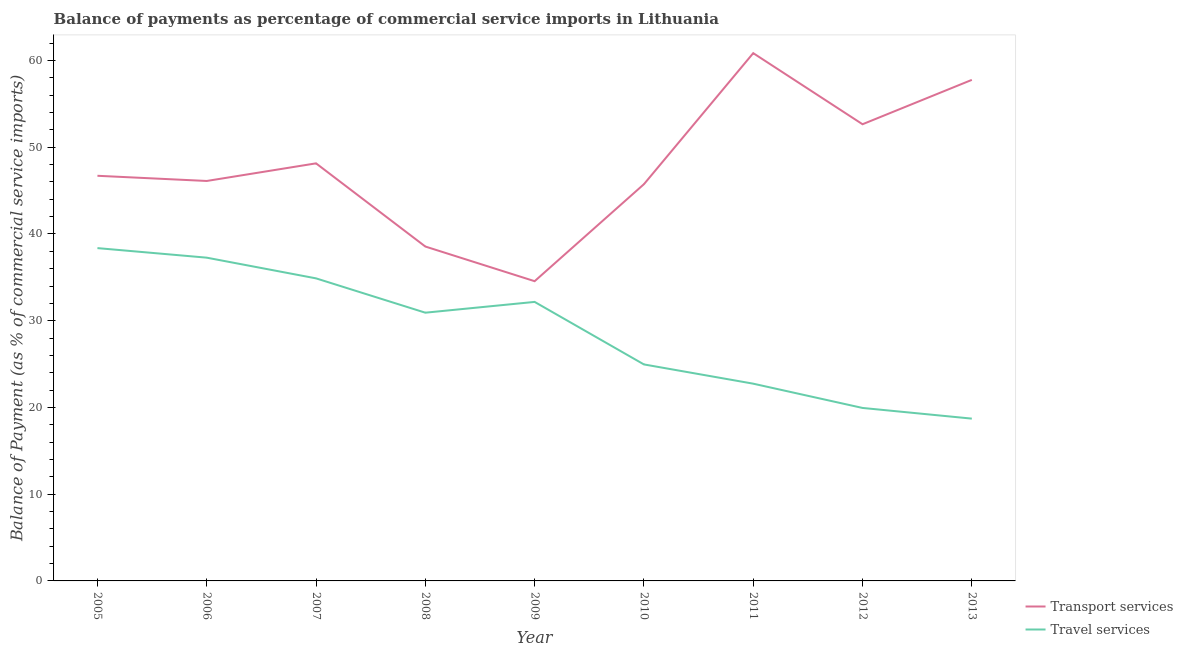What is the balance of payments of transport services in 2011?
Keep it short and to the point. 60.85. Across all years, what is the maximum balance of payments of travel services?
Your answer should be compact. 38.37. Across all years, what is the minimum balance of payments of transport services?
Offer a terse response. 34.56. In which year was the balance of payments of travel services minimum?
Make the answer very short. 2013. What is the total balance of payments of transport services in the graph?
Make the answer very short. 431.08. What is the difference between the balance of payments of travel services in 2005 and that in 2007?
Offer a terse response. 3.49. What is the difference between the balance of payments of travel services in 2007 and the balance of payments of transport services in 2008?
Provide a succinct answer. -3.67. What is the average balance of payments of travel services per year?
Make the answer very short. 28.89. In the year 2008, what is the difference between the balance of payments of travel services and balance of payments of transport services?
Make the answer very short. -7.63. What is the ratio of the balance of payments of travel services in 2006 to that in 2010?
Provide a succinct answer. 1.49. Is the balance of payments of transport services in 2006 less than that in 2013?
Make the answer very short. Yes. What is the difference between the highest and the second highest balance of payments of transport services?
Provide a succinct answer. 3.08. What is the difference between the highest and the lowest balance of payments of transport services?
Ensure brevity in your answer.  26.29. Is the sum of the balance of payments of transport services in 2012 and 2013 greater than the maximum balance of payments of travel services across all years?
Provide a short and direct response. Yes. How many lines are there?
Offer a terse response. 2. Are the values on the major ticks of Y-axis written in scientific E-notation?
Ensure brevity in your answer.  No. Where does the legend appear in the graph?
Give a very brief answer. Bottom right. How many legend labels are there?
Give a very brief answer. 2. How are the legend labels stacked?
Your answer should be compact. Vertical. What is the title of the graph?
Ensure brevity in your answer.  Balance of payments as percentage of commercial service imports in Lithuania. What is the label or title of the X-axis?
Give a very brief answer. Year. What is the label or title of the Y-axis?
Your answer should be compact. Balance of Payment (as % of commercial service imports). What is the Balance of Payment (as % of commercial service imports) in Transport services in 2005?
Ensure brevity in your answer.  46.71. What is the Balance of Payment (as % of commercial service imports) in Travel services in 2005?
Make the answer very short. 38.37. What is the Balance of Payment (as % of commercial service imports) in Transport services in 2006?
Provide a succinct answer. 46.11. What is the Balance of Payment (as % of commercial service imports) in Travel services in 2006?
Your answer should be compact. 37.27. What is the Balance of Payment (as % of commercial service imports) of Transport services in 2007?
Provide a short and direct response. 48.14. What is the Balance of Payment (as % of commercial service imports) in Travel services in 2007?
Your answer should be very brief. 34.88. What is the Balance of Payment (as % of commercial service imports) in Transport services in 2008?
Offer a very short reply. 38.55. What is the Balance of Payment (as % of commercial service imports) of Travel services in 2008?
Your answer should be very brief. 30.93. What is the Balance of Payment (as % of commercial service imports) in Transport services in 2009?
Offer a terse response. 34.56. What is the Balance of Payment (as % of commercial service imports) in Travel services in 2009?
Offer a terse response. 32.17. What is the Balance of Payment (as % of commercial service imports) of Transport services in 2010?
Make the answer very short. 45.74. What is the Balance of Payment (as % of commercial service imports) of Travel services in 2010?
Offer a very short reply. 24.96. What is the Balance of Payment (as % of commercial service imports) in Transport services in 2011?
Ensure brevity in your answer.  60.85. What is the Balance of Payment (as % of commercial service imports) in Travel services in 2011?
Keep it short and to the point. 22.74. What is the Balance of Payment (as % of commercial service imports) in Transport services in 2012?
Ensure brevity in your answer.  52.65. What is the Balance of Payment (as % of commercial service imports) in Travel services in 2012?
Your answer should be very brief. 19.94. What is the Balance of Payment (as % of commercial service imports) of Transport services in 2013?
Your answer should be compact. 57.77. What is the Balance of Payment (as % of commercial service imports) of Travel services in 2013?
Your answer should be compact. 18.71. Across all years, what is the maximum Balance of Payment (as % of commercial service imports) in Transport services?
Provide a succinct answer. 60.85. Across all years, what is the maximum Balance of Payment (as % of commercial service imports) in Travel services?
Your answer should be compact. 38.37. Across all years, what is the minimum Balance of Payment (as % of commercial service imports) in Transport services?
Your answer should be compact. 34.56. Across all years, what is the minimum Balance of Payment (as % of commercial service imports) in Travel services?
Give a very brief answer. 18.71. What is the total Balance of Payment (as % of commercial service imports) of Transport services in the graph?
Your response must be concise. 431.08. What is the total Balance of Payment (as % of commercial service imports) in Travel services in the graph?
Give a very brief answer. 259.97. What is the difference between the Balance of Payment (as % of commercial service imports) of Transport services in 2005 and that in 2006?
Ensure brevity in your answer.  0.6. What is the difference between the Balance of Payment (as % of commercial service imports) in Travel services in 2005 and that in 2006?
Keep it short and to the point. 1.1. What is the difference between the Balance of Payment (as % of commercial service imports) of Transport services in 2005 and that in 2007?
Your answer should be compact. -1.43. What is the difference between the Balance of Payment (as % of commercial service imports) of Travel services in 2005 and that in 2007?
Provide a short and direct response. 3.49. What is the difference between the Balance of Payment (as % of commercial service imports) of Transport services in 2005 and that in 2008?
Offer a terse response. 8.16. What is the difference between the Balance of Payment (as % of commercial service imports) in Travel services in 2005 and that in 2008?
Your response must be concise. 7.44. What is the difference between the Balance of Payment (as % of commercial service imports) of Transport services in 2005 and that in 2009?
Offer a terse response. 12.15. What is the difference between the Balance of Payment (as % of commercial service imports) in Travel services in 2005 and that in 2009?
Provide a short and direct response. 6.2. What is the difference between the Balance of Payment (as % of commercial service imports) in Transport services in 2005 and that in 2010?
Your answer should be very brief. 0.97. What is the difference between the Balance of Payment (as % of commercial service imports) in Travel services in 2005 and that in 2010?
Make the answer very short. 13.41. What is the difference between the Balance of Payment (as % of commercial service imports) of Transport services in 2005 and that in 2011?
Offer a very short reply. -14.14. What is the difference between the Balance of Payment (as % of commercial service imports) of Travel services in 2005 and that in 2011?
Offer a terse response. 15.63. What is the difference between the Balance of Payment (as % of commercial service imports) in Transport services in 2005 and that in 2012?
Give a very brief answer. -5.94. What is the difference between the Balance of Payment (as % of commercial service imports) of Travel services in 2005 and that in 2012?
Provide a short and direct response. 18.43. What is the difference between the Balance of Payment (as % of commercial service imports) of Transport services in 2005 and that in 2013?
Provide a short and direct response. -11.06. What is the difference between the Balance of Payment (as % of commercial service imports) in Travel services in 2005 and that in 2013?
Your answer should be very brief. 19.66. What is the difference between the Balance of Payment (as % of commercial service imports) of Transport services in 2006 and that in 2007?
Ensure brevity in your answer.  -2.03. What is the difference between the Balance of Payment (as % of commercial service imports) of Travel services in 2006 and that in 2007?
Keep it short and to the point. 2.39. What is the difference between the Balance of Payment (as % of commercial service imports) of Transport services in 2006 and that in 2008?
Your answer should be compact. 7.56. What is the difference between the Balance of Payment (as % of commercial service imports) in Travel services in 2006 and that in 2008?
Your answer should be very brief. 6.34. What is the difference between the Balance of Payment (as % of commercial service imports) in Transport services in 2006 and that in 2009?
Provide a short and direct response. 11.55. What is the difference between the Balance of Payment (as % of commercial service imports) in Travel services in 2006 and that in 2009?
Offer a very short reply. 5.1. What is the difference between the Balance of Payment (as % of commercial service imports) of Transport services in 2006 and that in 2010?
Give a very brief answer. 0.37. What is the difference between the Balance of Payment (as % of commercial service imports) in Travel services in 2006 and that in 2010?
Your answer should be compact. 12.31. What is the difference between the Balance of Payment (as % of commercial service imports) of Transport services in 2006 and that in 2011?
Give a very brief answer. -14.74. What is the difference between the Balance of Payment (as % of commercial service imports) of Travel services in 2006 and that in 2011?
Provide a short and direct response. 14.53. What is the difference between the Balance of Payment (as % of commercial service imports) in Transport services in 2006 and that in 2012?
Your response must be concise. -6.54. What is the difference between the Balance of Payment (as % of commercial service imports) of Travel services in 2006 and that in 2012?
Keep it short and to the point. 17.33. What is the difference between the Balance of Payment (as % of commercial service imports) of Transport services in 2006 and that in 2013?
Ensure brevity in your answer.  -11.65. What is the difference between the Balance of Payment (as % of commercial service imports) of Travel services in 2006 and that in 2013?
Your answer should be compact. 18.56. What is the difference between the Balance of Payment (as % of commercial service imports) in Transport services in 2007 and that in 2008?
Make the answer very short. 9.59. What is the difference between the Balance of Payment (as % of commercial service imports) of Travel services in 2007 and that in 2008?
Offer a very short reply. 3.96. What is the difference between the Balance of Payment (as % of commercial service imports) of Transport services in 2007 and that in 2009?
Give a very brief answer. 13.59. What is the difference between the Balance of Payment (as % of commercial service imports) of Travel services in 2007 and that in 2009?
Provide a short and direct response. 2.71. What is the difference between the Balance of Payment (as % of commercial service imports) in Transport services in 2007 and that in 2010?
Provide a short and direct response. 2.4. What is the difference between the Balance of Payment (as % of commercial service imports) in Travel services in 2007 and that in 2010?
Make the answer very short. 9.92. What is the difference between the Balance of Payment (as % of commercial service imports) in Transport services in 2007 and that in 2011?
Give a very brief answer. -12.71. What is the difference between the Balance of Payment (as % of commercial service imports) in Travel services in 2007 and that in 2011?
Your answer should be compact. 12.14. What is the difference between the Balance of Payment (as % of commercial service imports) in Transport services in 2007 and that in 2012?
Give a very brief answer. -4.51. What is the difference between the Balance of Payment (as % of commercial service imports) in Travel services in 2007 and that in 2012?
Your response must be concise. 14.94. What is the difference between the Balance of Payment (as % of commercial service imports) in Transport services in 2007 and that in 2013?
Keep it short and to the point. -9.62. What is the difference between the Balance of Payment (as % of commercial service imports) in Travel services in 2007 and that in 2013?
Keep it short and to the point. 16.17. What is the difference between the Balance of Payment (as % of commercial service imports) of Transport services in 2008 and that in 2009?
Give a very brief answer. 3.99. What is the difference between the Balance of Payment (as % of commercial service imports) of Travel services in 2008 and that in 2009?
Your answer should be very brief. -1.24. What is the difference between the Balance of Payment (as % of commercial service imports) of Transport services in 2008 and that in 2010?
Make the answer very short. -7.19. What is the difference between the Balance of Payment (as % of commercial service imports) of Travel services in 2008 and that in 2010?
Offer a terse response. 5.97. What is the difference between the Balance of Payment (as % of commercial service imports) of Transport services in 2008 and that in 2011?
Ensure brevity in your answer.  -22.3. What is the difference between the Balance of Payment (as % of commercial service imports) of Travel services in 2008 and that in 2011?
Keep it short and to the point. 8.18. What is the difference between the Balance of Payment (as % of commercial service imports) in Transport services in 2008 and that in 2012?
Your answer should be compact. -14.1. What is the difference between the Balance of Payment (as % of commercial service imports) in Travel services in 2008 and that in 2012?
Offer a terse response. 10.98. What is the difference between the Balance of Payment (as % of commercial service imports) in Transport services in 2008 and that in 2013?
Offer a very short reply. -19.21. What is the difference between the Balance of Payment (as % of commercial service imports) in Travel services in 2008 and that in 2013?
Your answer should be compact. 12.21. What is the difference between the Balance of Payment (as % of commercial service imports) in Transport services in 2009 and that in 2010?
Give a very brief answer. -11.18. What is the difference between the Balance of Payment (as % of commercial service imports) in Travel services in 2009 and that in 2010?
Your answer should be very brief. 7.21. What is the difference between the Balance of Payment (as % of commercial service imports) of Transport services in 2009 and that in 2011?
Keep it short and to the point. -26.29. What is the difference between the Balance of Payment (as % of commercial service imports) in Travel services in 2009 and that in 2011?
Your answer should be very brief. 9.43. What is the difference between the Balance of Payment (as % of commercial service imports) in Transport services in 2009 and that in 2012?
Give a very brief answer. -18.09. What is the difference between the Balance of Payment (as % of commercial service imports) of Travel services in 2009 and that in 2012?
Offer a very short reply. 12.23. What is the difference between the Balance of Payment (as % of commercial service imports) of Transport services in 2009 and that in 2013?
Your answer should be very brief. -23.21. What is the difference between the Balance of Payment (as % of commercial service imports) in Travel services in 2009 and that in 2013?
Offer a terse response. 13.46. What is the difference between the Balance of Payment (as % of commercial service imports) in Transport services in 2010 and that in 2011?
Your response must be concise. -15.11. What is the difference between the Balance of Payment (as % of commercial service imports) of Travel services in 2010 and that in 2011?
Make the answer very short. 2.22. What is the difference between the Balance of Payment (as % of commercial service imports) of Transport services in 2010 and that in 2012?
Offer a terse response. -6.91. What is the difference between the Balance of Payment (as % of commercial service imports) in Travel services in 2010 and that in 2012?
Offer a terse response. 5.02. What is the difference between the Balance of Payment (as % of commercial service imports) of Transport services in 2010 and that in 2013?
Provide a succinct answer. -12.03. What is the difference between the Balance of Payment (as % of commercial service imports) in Travel services in 2010 and that in 2013?
Ensure brevity in your answer.  6.25. What is the difference between the Balance of Payment (as % of commercial service imports) in Transport services in 2011 and that in 2012?
Your answer should be very brief. 8.2. What is the difference between the Balance of Payment (as % of commercial service imports) of Travel services in 2011 and that in 2012?
Provide a succinct answer. 2.8. What is the difference between the Balance of Payment (as % of commercial service imports) in Transport services in 2011 and that in 2013?
Offer a very short reply. 3.08. What is the difference between the Balance of Payment (as % of commercial service imports) of Travel services in 2011 and that in 2013?
Give a very brief answer. 4.03. What is the difference between the Balance of Payment (as % of commercial service imports) of Transport services in 2012 and that in 2013?
Offer a very short reply. -5.11. What is the difference between the Balance of Payment (as % of commercial service imports) of Travel services in 2012 and that in 2013?
Ensure brevity in your answer.  1.23. What is the difference between the Balance of Payment (as % of commercial service imports) of Transport services in 2005 and the Balance of Payment (as % of commercial service imports) of Travel services in 2006?
Your answer should be very brief. 9.44. What is the difference between the Balance of Payment (as % of commercial service imports) in Transport services in 2005 and the Balance of Payment (as % of commercial service imports) in Travel services in 2007?
Provide a short and direct response. 11.83. What is the difference between the Balance of Payment (as % of commercial service imports) of Transport services in 2005 and the Balance of Payment (as % of commercial service imports) of Travel services in 2008?
Provide a succinct answer. 15.78. What is the difference between the Balance of Payment (as % of commercial service imports) in Transport services in 2005 and the Balance of Payment (as % of commercial service imports) in Travel services in 2009?
Your answer should be compact. 14.54. What is the difference between the Balance of Payment (as % of commercial service imports) of Transport services in 2005 and the Balance of Payment (as % of commercial service imports) of Travel services in 2010?
Offer a terse response. 21.75. What is the difference between the Balance of Payment (as % of commercial service imports) of Transport services in 2005 and the Balance of Payment (as % of commercial service imports) of Travel services in 2011?
Your answer should be compact. 23.97. What is the difference between the Balance of Payment (as % of commercial service imports) of Transport services in 2005 and the Balance of Payment (as % of commercial service imports) of Travel services in 2012?
Your answer should be very brief. 26.77. What is the difference between the Balance of Payment (as % of commercial service imports) of Transport services in 2005 and the Balance of Payment (as % of commercial service imports) of Travel services in 2013?
Your answer should be very brief. 28. What is the difference between the Balance of Payment (as % of commercial service imports) of Transport services in 2006 and the Balance of Payment (as % of commercial service imports) of Travel services in 2007?
Provide a short and direct response. 11.23. What is the difference between the Balance of Payment (as % of commercial service imports) of Transport services in 2006 and the Balance of Payment (as % of commercial service imports) of Travel services in 2008?
Ensure brevity in your answer.  15.19. What is the difference between the Balance of Payment (as % of commercial service imports) in Transport services in 2006 and the Balance of Payment (as % of commercial service imports) in Travel services in 2009?
Your response must be concise. 13.94. What is the difference between the Balance of Payment (as % of commercial service imports) in Transport services in 2006 and the Balance of Payment (as % of commercial service imports) in Travel services in 2010?
Provide a succinct answer. 21.15. What is the difference between the Balance of Payment (as % of commercial service imports) in Transport services in 2006 and the Balance of Payment (as % of commercial service imports) in Travel services in 2011?
Offer a terse response. 23.37. What is the difference between the Balance of Payment (as % of commercial service imports) in Transport services in 2006 and the Balance of Payment (as % of commercial service imports) in Travel services in 2012?
Offer a terse response. 26.17. What is the difference between the Balance of Payment (as % of commercial service imports) of Transport services in 2006 and the Balance of Payment (as % of commercial service imports) of Travel services in 2013?
Your answer should be compact. 27.4. What is the difference between the Balance of Payment (as % of commercial service imports) of Transport services in 2007 and the Balance of Payment (as % of commercial service imports) of Travel services in 2008?
Your response must be concise. 17.22. What is the difference between the Balance of Payment (as % of commercial service imports) in Transport services in 2007 and the Balance of Payment (as % of commercial service imports) in Travel services in 2009?
Give a very brief answer. 15.97. What is the difference between the Balance of Payment (as % of commercial service imports) in Transport services in 2007 and the Balance of Payment (as % of commercial service imports) in Travel services in 2010?
Give a very brief answer. 23.18. What is the difference between the Balance of Payment (as % of commercial service imports) in Transport services in 2007 and the Balance of Payment (as % of commercial service imports) in Travel services in 2011?
Provide a succinct answer. 25.4. What is the difference between the Balance of Payment (as % of commercial service imports) in Transport services in 2007 and the Balance of Payment (as % of commercial service imports) in Travel services in 2012?
Offer a terse response. 28.2. What is the difference between the Balance of Payment (as % of commercial service imports) of Transport services in 2007 and the Balance of Payment (as % of commercial service imports) of Travel services in 2013?
Your response must be concise. 29.43. What is the difference between the Balance of Payment (as % of commercial service imports) of Transport services in 2008 and the Balance of Payment (as % of commercial service imports) of Travel services in 2009?
Your answer should be very brief. 6.38. What is the difference between the Balance of Payment (as % of commercial service imports) in Transport services in 2008 and the Balance of Payment (as % of commercial service imports) in Travel services in 2010?
Give a very brief answer. 13.59. What is the difference between the Balance of Payment (as % of commercial service imports) of Transport services in 2008 and the Balance of Payment (as % of commercial service imports) of Travel services in 2011?
Keep it short and to the point. 15.81. What is the difference between the Balance of Payment (as % of commercial service imports) of Transport services in 2008 and the Balance of Payment (as % of commercial service imports) of Travel services in 2012?
Offer a terse response. 18.61. What is the difference between the Balance of Payment (as % of commercial service imports) of Transport services in 2008 and the Balance of Payment (as % of commercial service imports) of Travel services in 2013?
Offer a very short reply. 19.84. What is the difference between the Balance of Payment (as % of commercial service imports) in Transport services in 2009 and the Balance of Payment (as % of commercial service imports) in Travel services in 2010?
Make the answer very short. 9.6. What is the difference between the Balance of Payment (as % of commercial service imports) of Transport services in 2009 and the Balance of Payment (as % of commercial service imports) of Travel services in 2011?
Make the answer very short. 11.82. What is the difference between the Balance of Payment (as % of commercial service imports) of Transport services in 2009 and the Balance of Payment (as % of commercial service imports) of Travel services in 2012?
Ensure brevity in your answer.  14.61. What is the difference between the Balance of Payment (as % of commercial service imports) of Transport services in 2009 and the Balance of Payment (as % of commercial service imports) of Travel services in 2013?
Offer a very short reply. 15.85. What is the difference between the Balance of Payment (as % of commercial service imports) of Transport services in 2010 and the Balance of Payment (as % of commercial service imports) of Travel services in 2011?
Provide a short and direct response. 23. What is the difference between the Balance of Payment (as % of commercial service imports) of Transport services in 2010 and the Balance of Payment (as % of commercial service imports) of Travel services in 2012?
Provide a short and direct response. 25.8. What is the difference between the Balance of Payment (as % of commercial service imports) of Transport services in 2010 and the Balance of Payment (as % of commercial service imports) of Travel services in 2013?
Keep it short and to the point. 27.03. What is the difference between the Balance of Payment (as % of commercial service imports) in Transport services in 2011 and the Balance of Payment (as % of commercial service imports) in Travel services in 2012?
Provide a succinct answer. 40.91. What is the difference between the Balance of Payment (as % of commercial service imports) in Transport services in 2011 and the Balance of Payment (as % of commercial service imports) in Travel services in 2013?
Offer a terse response. 42.14. What is the difference between the Balance of Payment (as % of commercial service imports) in Transport services in 2012 and the Balance of Payment (as % of commercial service imports) in Travel services in 2013?
Provide a short and direct response. 33.94. What is the average Balance of Payment (as % of commercial service imports) of Transport services per year?
Ensure brevity in your answer.  47.9. What is the average Balance of Payment (as % of commercial service imports) of Travel services per year?
Provide a short and direct response. 28.89. In the year 2005, what is the difference between the Balance of Payment (as % of commercial service imports) of Transport services and Balance of Payment (as % of commercial service imports) of Travel services?
Offer a terse response. 8.34. In the year 2006, what is the difference between the Balance of Payment (as % of commercial service imports) of Transport services and Balance of Payment (as % of commercial service imports) of Travel services?
Offer a very short reply. 8.84. In the year 2007, what is the difference between the Balance of Payment (as % of commercial service imports) in Transport services and Balance of Payment (as % of commercial service imports) in Travel services?
Your answer should be very brief. 13.26. In the year 2008, what is the difference between the Balance of Payment (as % of commercial service imports) in Transport services and Balance of Payment (as % of commercial service imports) in Travel services?
Make the answer very short. 7.63. In the year 2009, what is the difference between the Balance of Payment (as % of commercial service imports) in Transport services and Balance of Payment (as % of commercial service imports) in Travel services?
Provide a succinct answer. 2.39. In the year 2010, what is the difference between the Balance of Payment (as % of commercial service imports) of Transport services and Balance of Payment (as % of commercial service imports) of Travel services?
Your answer should be very brief. 20.78. In the year 2011, what is the difference between the Balance of Payment (as % of commercial service imports) of Transport services and Balance of Payment (as % of commercial service imports) of Travel services?
Your answer should be very brief. 38.11. In the year 2012, what is the difference between the Balance of Payment (as % of commercial service imports) in Transport services and Balance of Payment (as % of commercial service imports) in Travel services?
Offer a very short reply. 32.71. In the year 2013, what is the difference between the Balance of Payment (as % of commercial service imports) of Transport services and Balance of Payment (as % of commercial service imports) of Travel services?
Make the answer very short. 39.05. What is the ratio of the Balance of Payment (as % of commercial service imports) in Travel services in 2005 to that in 2006?
Offer a very short reply. 1.03. What is the ratio of the Balance of Payment (as % of commercial service imports) of Transport services in 2005 to that in 2007?
Give a very brief answer. 0.97. What is the ratio of the Balance of Payment (as % of commercial service imports) in Travel services in 2005 to that in 2007?
Offer a very short reply. 1.1. What is the ratio of the Balance of Payment (as % of commercial service imports) in Transport services in 2005 to that in 2008?
Ensure brevity in your answer.  1.21. What is the ratio of the Balance of Payment (as % of commercial service imports) of Travel services in 2005 to that in 2008?
Offer a very short reply. 1.24. What is the ratio of the Balance of Payment (as % of commercial service imports) of Transport services in 2005 to that in 2009?
Your answer should be very brief. 1.35. What is the ratio of the Balance of Payment (as % of commercial service imports) in Travel services in 2005 to that in 2009?
Your response must be concise. 1.19. What is the ratio of the Balance of Payment (as % of commercial service imports) of Transport services in 2005 to that in 2010?
Ensure brevity in your answer.  1.02. What is the ratio of the Balance of Payment (as % of commercial service imports) of Travel services in 2005 to that in 2010?
Make the answer very short. 1.54. What is the ratio of the Balance of Payment (as % of commercial service imports) in Transport services in 2005 to that in 2011?
Your answer should be very brief. 0.77. What is the ratio of the Balance of Payment (as % of commercial service imports) of Travel services in 2005 to that in 2011?
Give a very brief answer. 1.69. What is the ratio of the Balance of Payment (as % of commercial service imports) of Transport services in 2005 to that in 2012?
Offer a very short reply. 0.89. What is the ratio of the Balance of Payment (as % of commercial service imports) of Travel services in 2005 to that in 2012?
Ensure brevity in your answer.  1.92. What is the ratio of the Balance of Payment (as % of commercial service imports) in Transport services in 2005 to that in 2013?
Offer a terse response. 0.81. What is the ratio of the Balance of Payment (as % of commercial service imports) of Travel services in 2005 to that in 2013?
Offer a terse response. 2.05. What is the ratio of the Balance of Payment (as % of commercial service imports) of Transport services in 2006 to that in 2007?
Make the answer very short. 0.96. What is the ratio of the Balance of Payment (as % of commercial service imports) in Travel services in 2006 to that in 2007?
Provide a short and direct response. 1.07. What is the ratio of the Balance of Payment (as % of commercial service imports) in Transport services in 2006 to that in 2008?
Your answer should be compact. 1.2. What is the ratio of the Balance of Payment (as % of commercial service imports) of Travel services in 2006 to that in 2008?
Ensure brevity in your answer.  1.21. What is the ratio of the Balance of Payment (as % of commercial service imports) in Transport services in 2006 to that in 2009?
Give a very brief answer. 1.33. What is the ratio of the Balance of Payment (as % of commercial service imports) of Travel services in 2006 to that in 2009?
Provide a succinct answer. 1.16. What is the ratio of the Balance of Payment (as % of commercial service imports) of Transport services in 2006 to that in 2010?
Make the answer very short. 1.01. What is the ratio of the Balance of Payment (as % of commercial service imports) of Travel services in 2006 to that in 2010?
Give a very brief answer. 1.49. What is the ratio of the Balance of Payment (as % of commercial service imports) in Transport services in 2006 to that in 2011?
Ensure brevity in your answer.  0.76. What is the ratio of the Balance of Payment (as % of commercial service imports) of Travel services in 2006 to that in 2011?
Keep it short and to the point. 1.64. What is the ratio of the Balance of Payment (as % of commercial service imports) of Transport services in 2006 to that in 2012?
Keep it short and to the point. 0.88. What is the ratio of the Balance of Payment (as % of commercial service imports) of Travel services in 2006 to that in 2012?
Ensure brevity in your answer.  1.87. What is the ratio of the Balance of Payment (as % of commercial service imports) in Transport services in 2006 to that in 2013?
Provide a short and direct response. 0.8. What is the ratio of the Balance of Payment (as % of commercial service imports) of Travel services in 2006 to that in 2013?
Your answer should be compact. 1.99. What is the ratio of the Balance of Payment (as % of commercial service imports) of Transport services in 2007 to that in 2008?
Ensure brevity in your answer.  1.25. What is the ratio of the Balance of Payment (as % of commercial service imports) in Travel services in 2007 to that in 2008?
Keep it short and to the point. 1.13. What is the ratio of the Balance of Payment (as % of commercial service imports) of Transport services in 2007 to that in 2009?
Keep it short and to the point. 1.39. What is the ratio of the Balance of Payment (as % of commercial service imports) in Travel services in 2007 to that in 2009?
Your answer should be compact. 1.08. What is the ratio of the Balance of Payment (as % of commercial service imports) of Transport services in 2007 to that in 2010?
Your answer should be compact. 1.05. What is the ratio of the Balance of Payment (as % of commercial service imports) in Travel services in 2007 to that in 2010?
Your response must be concise. 1.4. What is the ratio of the Balance of Payment (as % of commercial service imports) of Transport services in 2007 to that in 2011?
Your answer should be compact. 0.79. What is the ratio of the Balance of Payment (as % of commercial service imports) of Travel services in 2007 to that in 2011?
Your answer should be very brief. 1.53. What is the ratio of the Balance of Payment (as % of commercial service imports) of Transport services in 2007 to that in 2012?
Your answer should be very brief. 0.91. What is the ratio of the Balance of Payment (as % of commercial service imports) in Travel services in 2007 to that in 2012?
Provide a succinct answer. 1.75. What is the ratio of the Balance of Payment (as % of commercial service imports) in Transport services in 2007 to that in 2013?
Provide a succinct answer. 0.83. What is the ratio of the Balance of Payment (as % of commercial service imports) of Travel services in 2007 to that in 2013?
Provide a succinct answer. 1.86. What is the ratio of the Balance of Payment (as % of commercial service imports) of Transport services in 2008 to that in 2009?
Your response must be concise. 1.12. What is the ratio of the Balance of Payment (as % of commercial service imports) in Travel services in 2008 to that in 2009?
Provide a short and direct response. 0.96. What is the ratio of the Balance of Payment (as % of commercial service imports) in Transport services in 2008 to that in 2010?
Provide a succinct answer. 0.84. What is the ratio of the Balance of Payment (as % of commercial service imports) in Travel services in 2008 to that in 2010?
Your answer should be compact. 1.24. What is the ratio of the Balance of Payment (as % of commercial service imports) in Transport services in 2008 to that in 2011?
Give a very brief answer. 0.63. What is the ratio of the Balance of Payment (as % of commercial service imports) in Travel services in 2008 to that in 2011?
Your answer should be very brief. 1.36. What is the ratio of the Balance of Payment (as % of commercial service imports) of Transport services in 2008 to that in 2012?
Offer a very short reply. 0.73. What is the ratio of the Balance of Payment (as % of commercial service imports) in Travel services in 2008 to that in 2012?
Keep it short and to the point. 1.55. What is the ratio of the Balance of Payment (as % of commercial service imports) of Transport services in 2008 to that in 2013?
Give a very brief answer. 0.67. What is the ratio of the Balance of Payment (as % of commercial service imports) of Travel services in 2008 to that in 2013?
Ensure brevity in your answer.  1.65. What is the ratio of the Balance of Payment (as % of commercial service imports) of Transport services in 2009 to that in 2010?
Ensure brevity in your answer.  0.76. What is the ratio of the Balance of Payment (as % of commercial service imports) in Travel services in 2009 to that in 2010?
Offer a terse response. 1.29. What is the ratio of the Balance of Payment (as % of commercial service imports) in Transport services in 2009 to that in 2011?
Offer a terse response. 0.57. What is the ratio of the Balance of Payment (as % of commercial service imports) of Travel services in 2009 to that in 2011?
Provide a succinct answer. 1.41. What is the ratio of the Balance of Payment (as % of commercial service imports) in Transport services in 2009 to that in 2012?
Your answer should be very brief. 0.66. What is the ratio of the Balance of Payment (as % of commercial service imports) in Travel services in 2009 to that in 2012?
Keep it short and to the point. 1.61. What is the ratio of the Balance of Payment (as % of commercial service imports) in Transport services in 2009 to that in 2013?
Your response must be concise. 0.6. What is the ratio of the Balance of Payment (as % of commercial service imports) of Travel services in 2009 to that in 2013?
Your response must be concise. 1.72. What is the ratio of the Balance of Payment (as % of commercial service imports) of Transport services in 2010 to that in 2011?
Make the answer very short. 0.75. What is the ratio of the Balance of Payment (as % of commercial service imports) in Travel services in 2010 to that in 2011?
Provide a succinct answer. 1.1. What is the ratio of the Balance of Payment (as % of commercial service imports) of Transport services in 2010 to that in 2012?
Give a very brief answer. 0.87. What is the ratio of the Balance of Payment (as % of commercial service imports) of Travel services in 2010 to that in 2012?
Offer a very short reply. 1.25. What is the ratio of the Balance of Payment (as % of commercial service imports) of Transport services in 2010 to that in 2013?
Offer a very short reply. 0.79. What is the ratio of the Balance of Payment (as % of commercial service imports) of Travel services in 2010 to that in 2013?
Offer a very short reply. 1.33. What is the ratio of the Balance of Payment (as % of commercial service imports) in Transport services in 2011 to that in 2012?
Keep it short and to the point. 1.16. What is the ratio of the Balance of Payment (as % of commercial service imports) of Travel services in 2011 to that in 2012?
Provide a short and direct response. 1.14. What is the ratio of the Balance of Payment (as % of commercial service imports) of Transport services in 2011 to that in 2013?
Your answer should be compact. 1.05. What is the ratio of the Balance of Payment (as % of commercial service imports) in Travel services in 2011 to that in 2013?
Your answer should be compact. 1.22. What is the ratio of the Balance of Payment (as % of commercial service imports) of Transport services in 2012 to that in 2013?
Keep it short and to the point. 0.91. What is the ratio of the Balance of Payment (as % of commercial service imports) in Travel services in 2012 to that in 2013?
Offer a terse response. 1.07. What is the difference between the highest and the second highest Balance of Payment (as % of commercial service imports) of Transport services?
Keep it short and to the point. 3.08. What is the difference between the highest and the second highest Balance of Payment (as % of commercial service imports) of Travel services?
Keep it short and to the point. 1.1. What is the difference between the highest and the lowest Balance of Payment (as % of commercial service imports) in Transport services?
Your answer should be very brief. 26.29. What is the difference between the highest and the lowest Balance of Payment (as % of commercial service imports) in Travel services?
Keep it short and to the point. 19.66. 